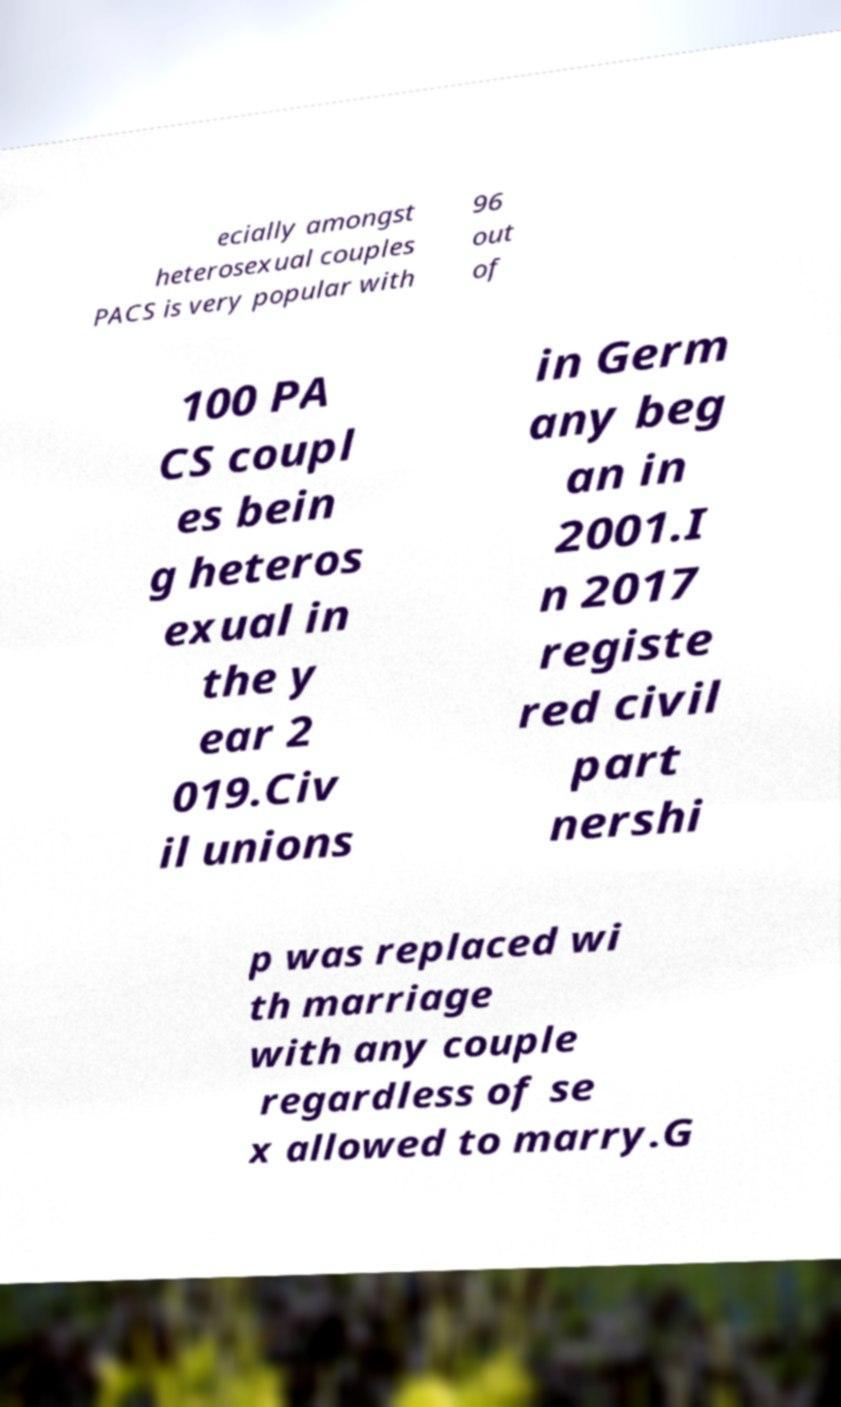I need the written content from this picture converted into text. Can you do that? ecially amongst heterosexual couples PACS is very popular with 96 out of 100 PA CS coupl es bein g heteros exual in the y ear 2 019.Civ il unions in Germ any beg an in 2001.I n 2017 registe red civil part nershi p was replaced wi th marriage with any couple regardless of se x allowed to marry.G 